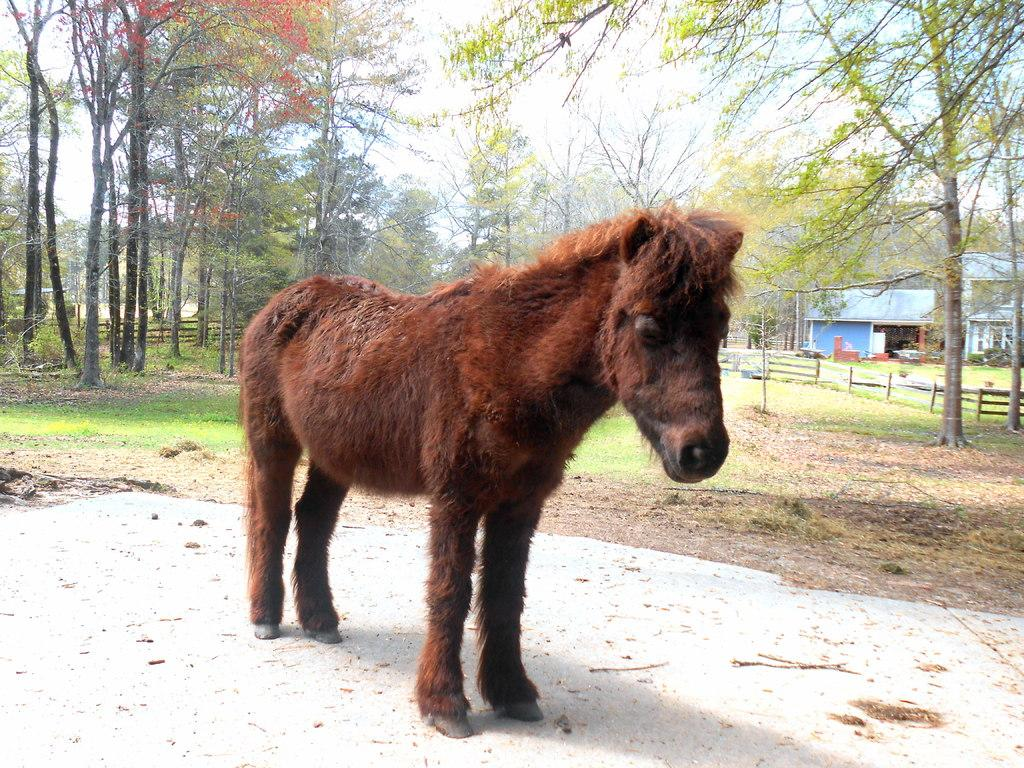What type of animal is in the image? The type of animal cannot be determined from the provided facts. What can be found on the ground in the image? There are leaves on the ground in the image. What is present in the image that provides shade or oxygen? There are trees in the image. What type of structures can be seen in the image? There are houses in the image. What is used to separate properties or areas in the image? There are fences in the image. What type of vegetation is present in the image? There is grass in the image. What part of the natural environment is visible in the image? The sky is visible in the image. What type of sock is the creator wearing while working on the image? There is no information about a creator or their sock in the provided facts, and therefore this question cannot be answered. 